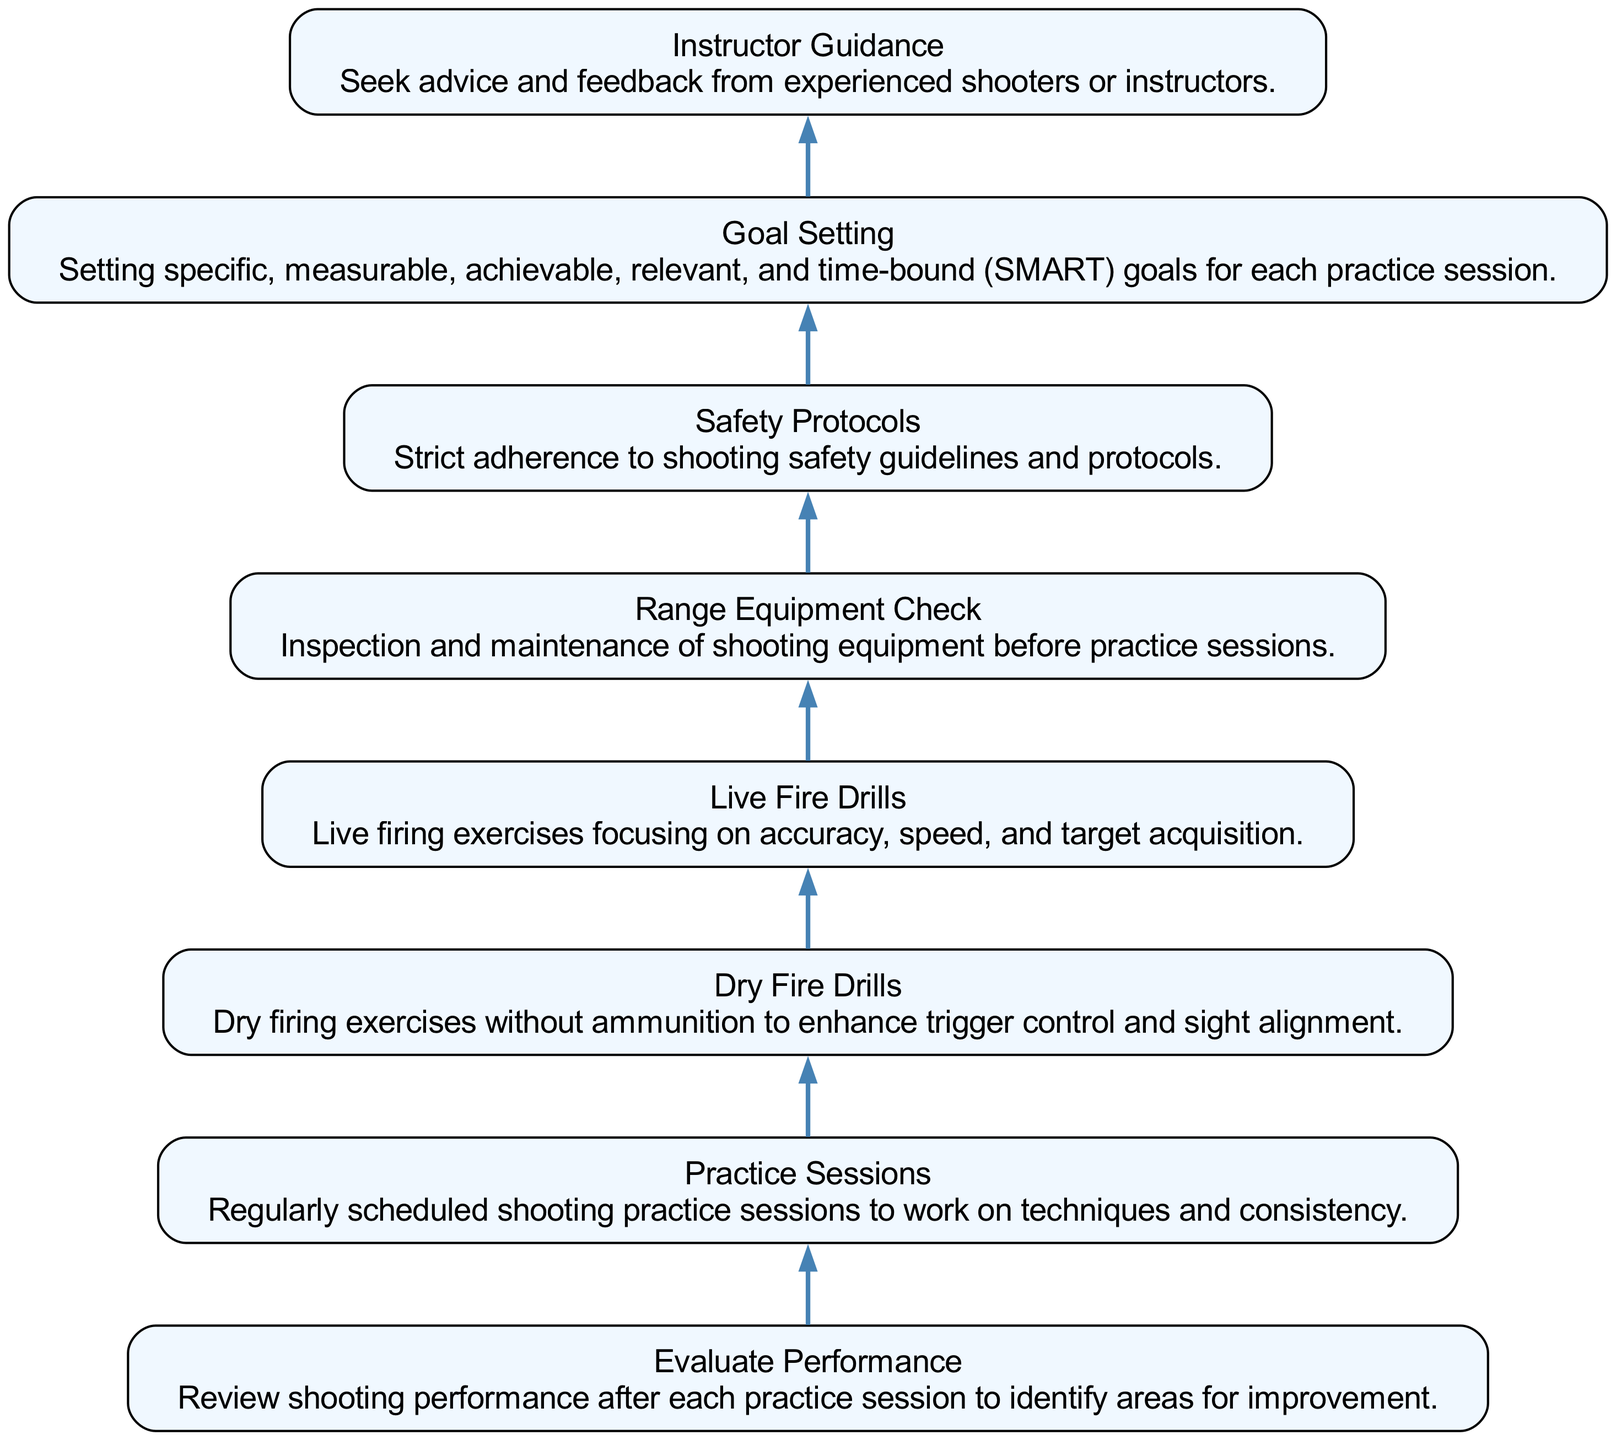What is the first step in the practice plan? The flowchart indicates that the first step at the bottom is "Goal Setting," which is the initial action leading to the following steps.
Answer: Goal Setting How many components are listed in the practice plan? By counting the components displayed in the flowchart, there are eight distinct elements involved in the precision shooting practice plan.
Answer: Eight What is the last component of the practice plan? The final node at the top of the flowchart represents "Evaluate Performance," which comes after all the practice activities have been completed.
Answer: Evaluate Performance What component follows 'Live Fire Drills'? In the flow from the bottom to the top of the diagram, "Live Fire Drills" is followed by the "Evaluate Performance" step indicating a review of the practice session.
Answer: Evaluate Performance Which component emphasizes safety? The diagram clearly states "Safety Protocols," which focuses on maintaining proper safety practices during shooting.
Answer: Safety Protocols How many types of drills are mentioned in the practice plan? The flowchart specifies two types of drills: "Dry Fire Drills" and "Live Fire Drills," highlighting the importance of both in training.
Answer: Two Which component requires feedback from experienced shooters? Seeking input from more knowledgeable individuals is captured in the "Instructor Guidance" node, emphasizing the value of expert advice.
Answer: Instructor Guidance What links 'Range Equipment Check' to 'Practice Sessions'? The flowchart indicates a direct connection between "Range Equipment Check" and "Practice Sessions," suggesting that equipment must be checked before practicing.
Answer: Practice Sessions Which steps are directly involved in improving shooting skills? To improve shooting skills, the plan includes "Dry Fire Drills," "Live Fire Drills," and "Instructor Guidance," all directly contributing to skill enhancement.
Answer: Dry Fire Drills, Live Fire Drills, Instructor Guidance 